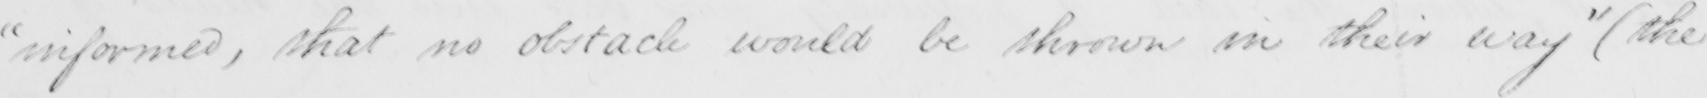Please transcribe the handwritten text in this image. " informed , that no obstacle would be shown in their way "   ( the 